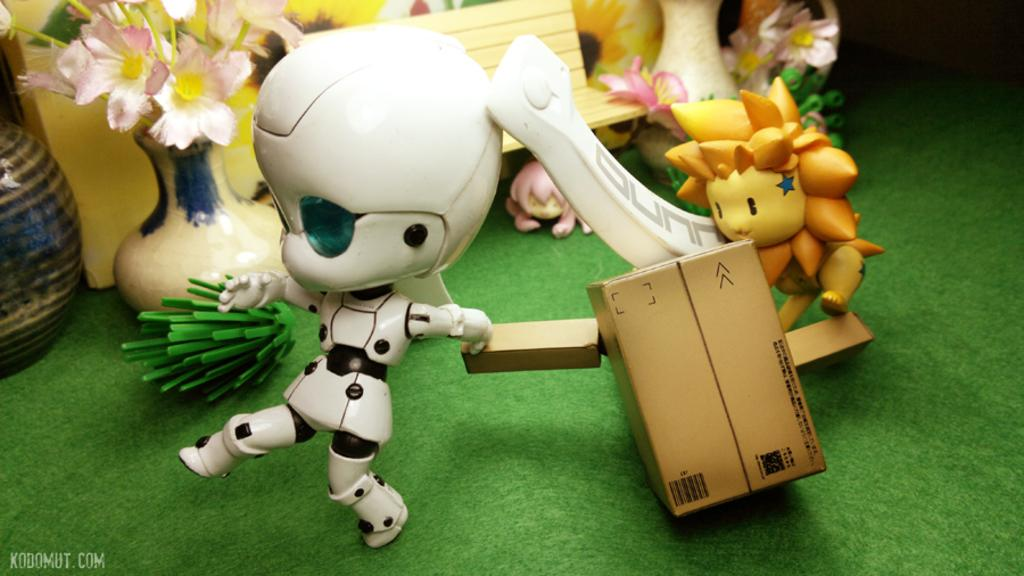What type of objects can be seen in the image? There are toys and flower vases in the image. Can you describe the toys in the image? Unfortunately, the facts provided do not give specific details about the toys. How many flower vases are present in the image? The facts provided do not specify the number of flower vases in the image. What type of secretary is present in the image? There is no secretary present in the image. What material is the steel stop made of in the image? There is no steel stop present in the image. 